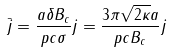Convert formula to latex. <formula><loc_0><loc_0><loc_500><loc_500>\bar { j } = \frac { a \delta B _ { c } } { p c \sigma } j = \frac { 3 \pi \sqrt { 2 { \kappa } } a } { p c B _ { c } } j</formula> 